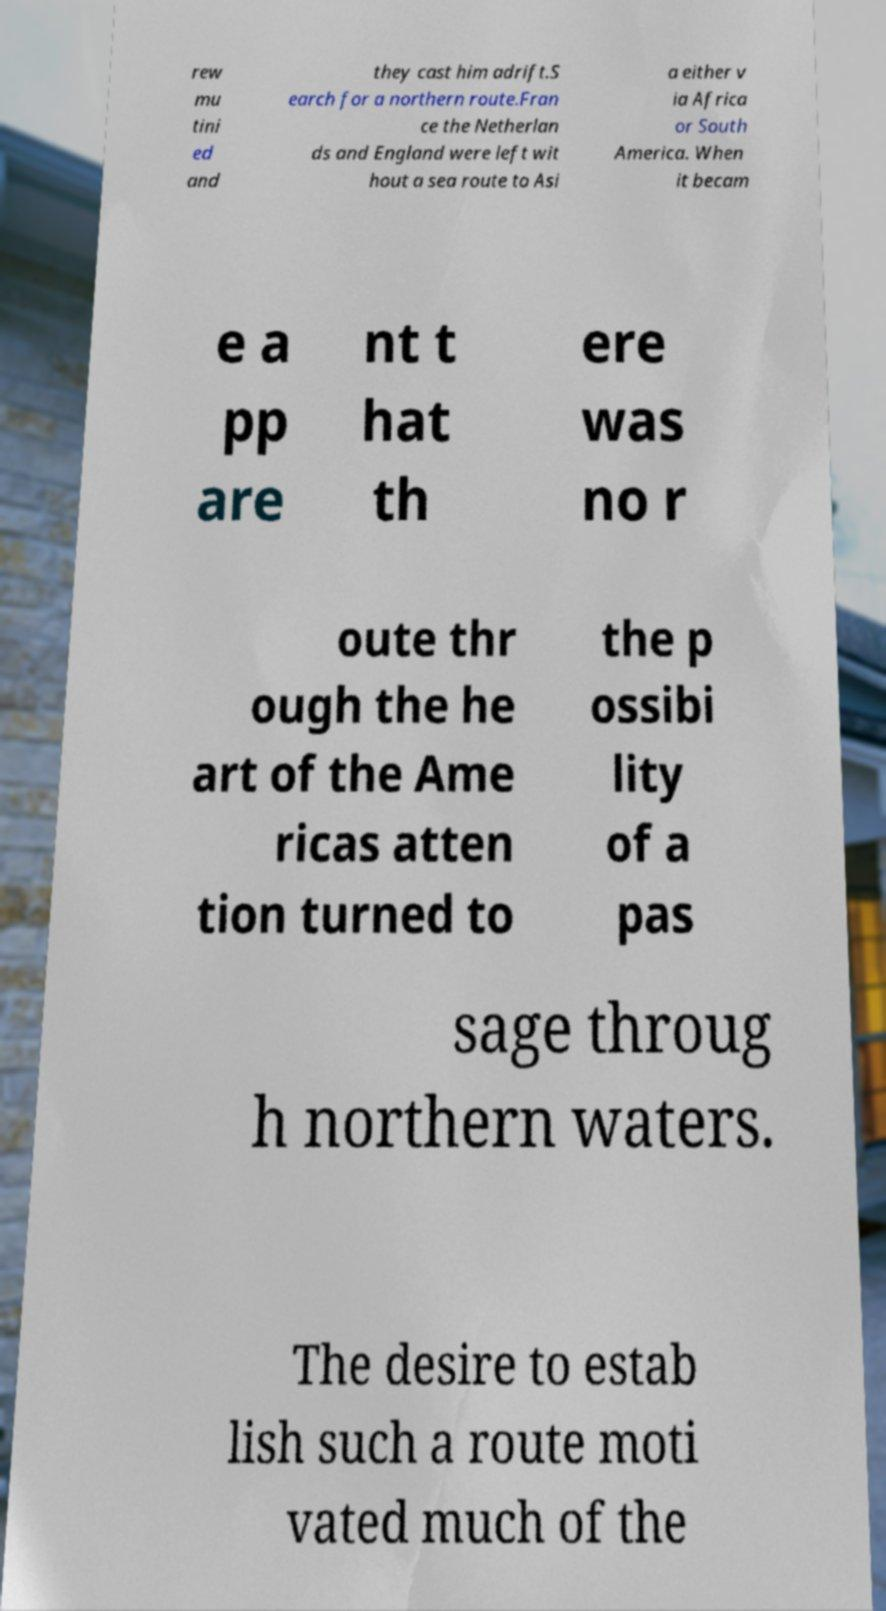I need the written content from this picture converted into text. Can you do that? rew mu tini ed and they cast him adrift.S earch for a northern route.Fran ce the Netherlan ds and England were left wit hout a sea route to Asi a either v ia Africa or South America. When it becam e a pp are nt t hat th ere was no r oute thr ough the he art of the Ame ricas atten tion turned to the p ossibi lity of a pas sage throug h northern waters. The desire to estab lish such a route moti vated much of the 